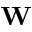Convert formula to latex. <formula><loc_0><loc_0><loc_500><loc_500>{ W }</formula> 